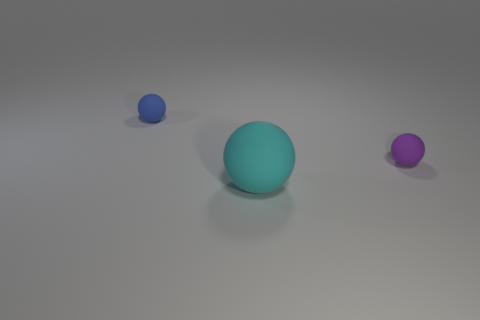What is the shape of the purple thing?
Keep it short and to the point. Sphere. Is the number of tiny brown matte objects less than the number of purple rubber spheres?
Offer a terse response. Yes. Is there any other thing that has the same size as the blue ball?
Ensure brevity in your answer.  Yes. There is a tiny blue object that is the same shape as the cyan matte thing; what is its material?
Give a very brief answer. Rubber. Is the number of small matte balls greater than the number of blue objects?
Keep it short and to the point. Yes. How many other things are the same color as the large object?
Your answer should be very brief. 0. Does the purple object have the same material as the thing in front of the small purple matte thing?
Keep it short and to the point. Yes. There is a tiny sphere that is on the right side of the ball in front of the purple matte thing; what number of big cyan matte things are to the right of it?
Your answer should be compact. 0. Are there fewer blue matte spheres in front of the small blue matte ball than spheres in front of the small purple object?
Your answer should be compact. Yes. What number of other objects are there of the same material as the large sphere?
Provide a short and direct response. 2. 